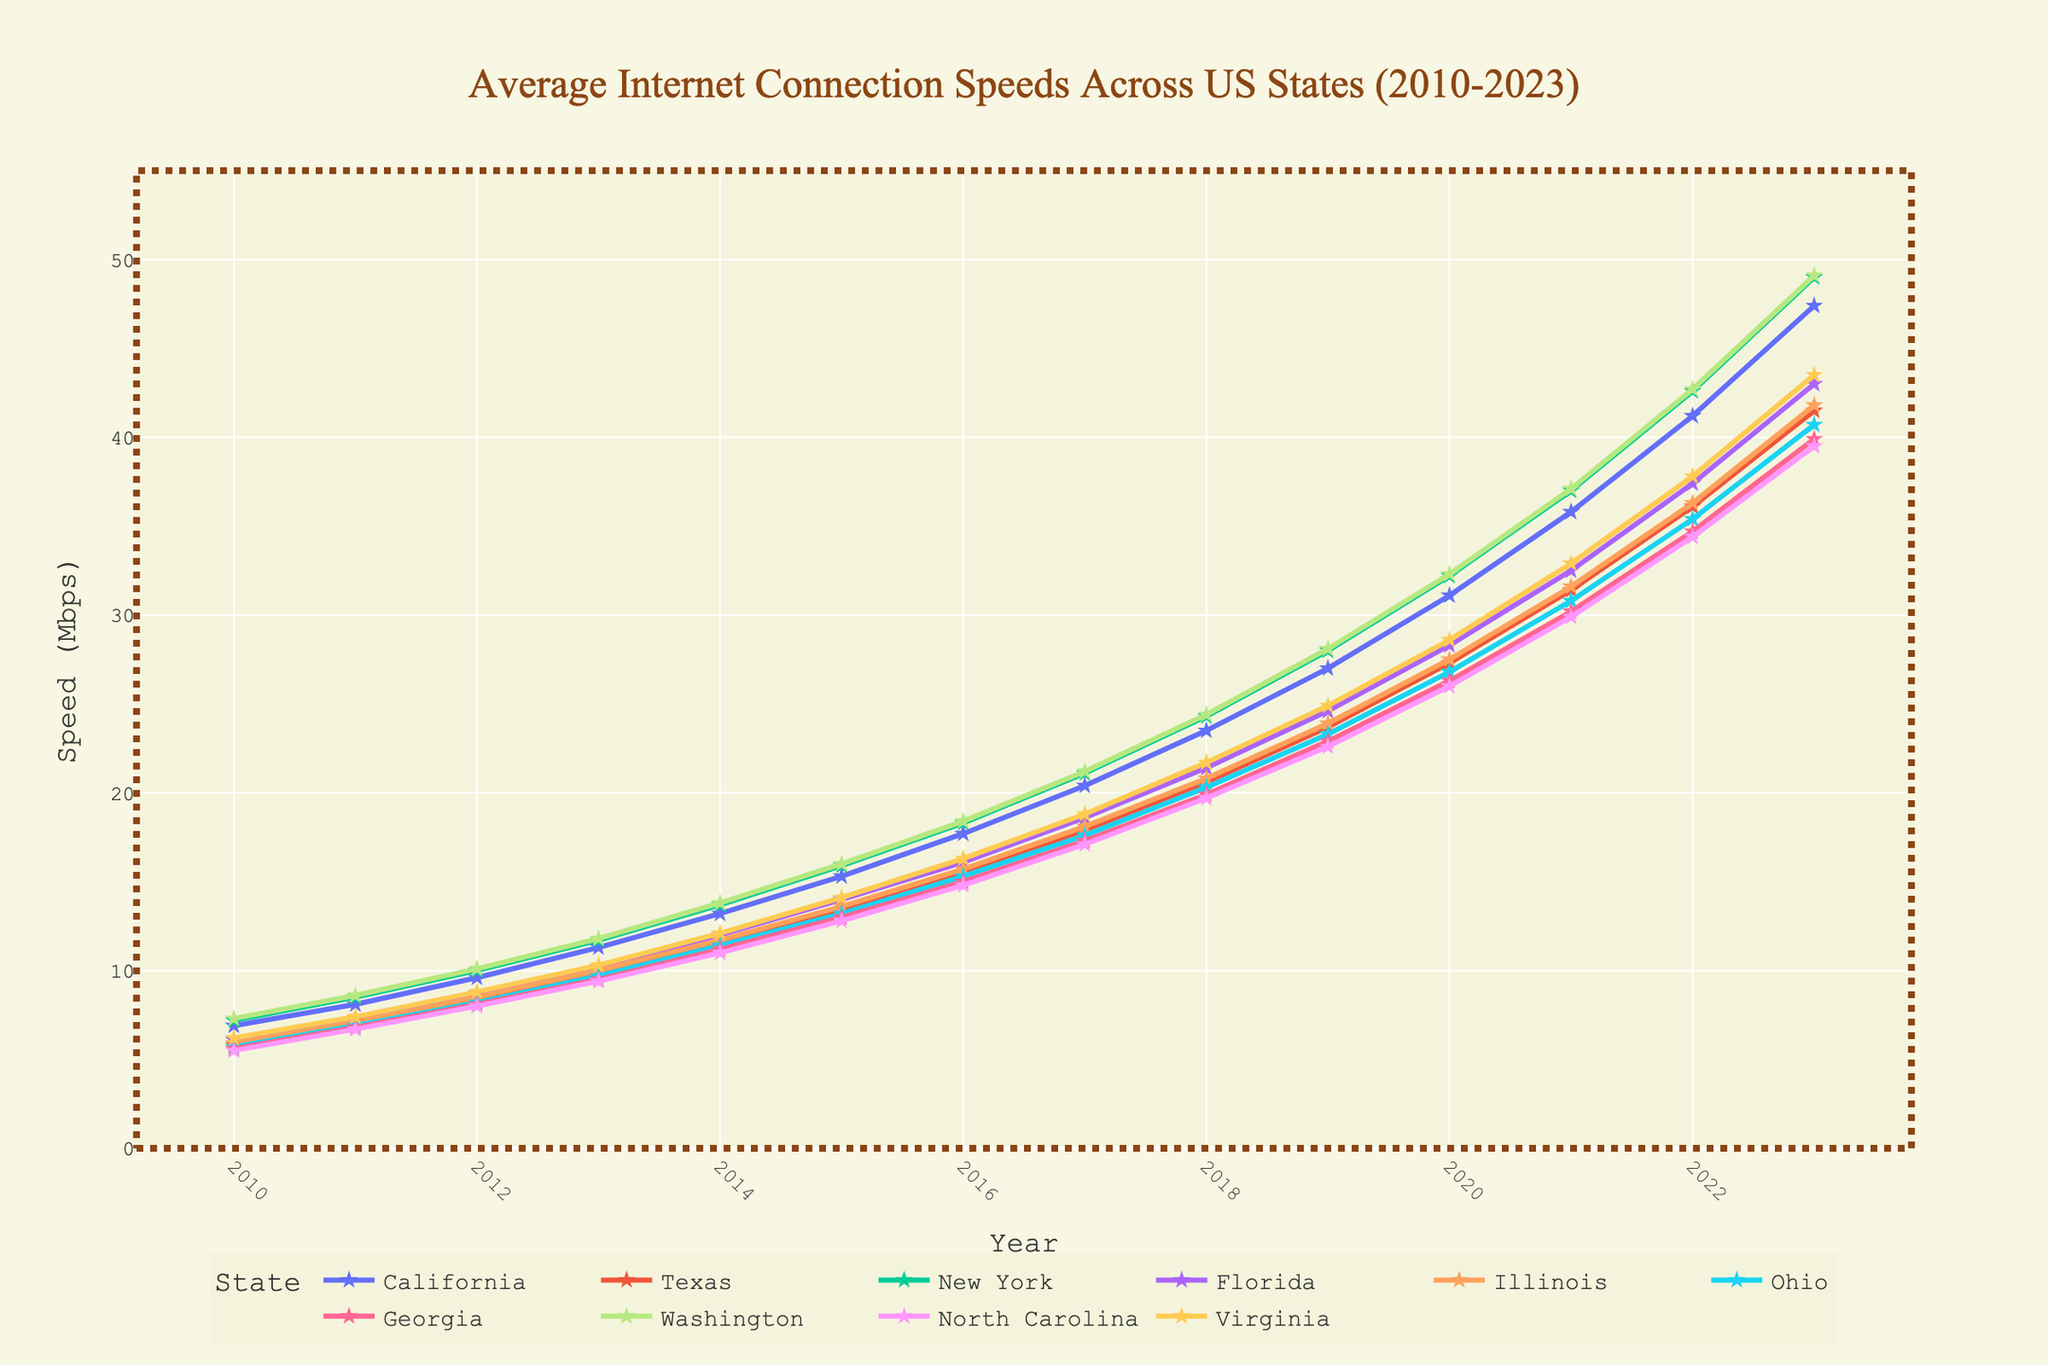What's the fastest average internet speed in California and when was it recorded? By observing the chart, look for the line representing California and find the highest point on that line. Note the year it corresponds to.
Answer: 47.4 Mbps in 2023 Which state had the slowest average internet speed in 2011? Check the values for each state in 2011 and identify the smallest value among them.
Answer: Georgia with 6.8 Mbps By how much did average internet speeds increase in Texas from 2013 to 2018? Identify the data points for Texas in 2013 and 2018. Subtract the 2013 value from the 2018 value. Specifically, 20.6 - 9.8.
Answer: 10.8 Mbps Which two states had the most similar average internet speeds in 2020? Examine the values for each state in 2020 and find two states with the closest speed values.
Answer: Illinois and Ohio, both with 27.5 and 26.8 Mbps, respectively In which year did New York surpass an average internet speed of 40 Mbps? Track the line representing New York. The first year where the speed crosses 40 Mbps is the year of interest.
Answer: 2022 Compare the average internet speeds in Washington and Virginia in 2015. Which state had higher speeds? Locate the data points for Washington and Virginia in 2015 and compare the two values.
Answer: Washington with 16.0 Mbps vs. Virginia with 14.1 Mbps What was the percentage increase in average internet speed for Florida from 2010 to 2023? Calculate the difference between 2023 and 2010 values for Florida. Divide this difference by the 2010 value and multiply by 100 to get the percentage. (43.0 - 6.1) / 6.1 * 100.
Answer: Approximately 605% From 2010 to 2013, which state showed the least improvement in average internet speed? Calculate the difference between 2013 and 2010 speeds for each state and find the smallest increase.
Answer: Georgia with only 9.5 - 5.6 = 3.9 Mbps Which state has shown a consistent increase in internet speeds every year from 2010 to 2023 without any decrease in any year? Trace each line on the chart from 2010 to 2023 to ensure there’s no dip for any year.
Answer: Washington 